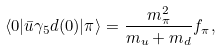<formula> <loc_0><loc_0><loc_500><loc_500>\langle 0 | \bar { u } \gamma _ { 5 } d ( 0 ) | \pi \rangle = \frac { m ^ { 2 } _ { \pi } } { m _ { u } + m _ { d } } f _ { \pi } ,</formula> 